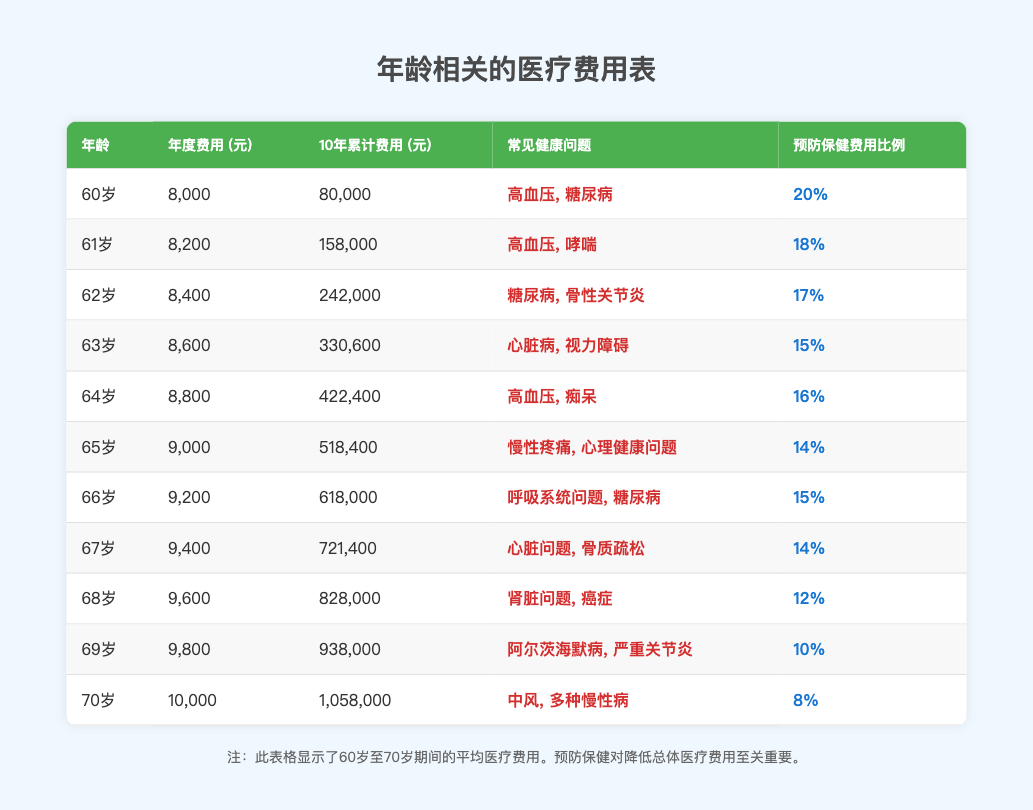What is the annual healthcare cost for a 65-year-old? The table shows that the annual cost for a 65-year-old is listed under "年度费用" as 9,000元.
Answer: 9,000元 What are the common health issues for a 67-year-old? According to the table, the common health issues for a 67-year-old are "心脏问题, 骨质疏松".
Answer: 心脏问题, 骨质疏松 What is the cumulative healthcare cost over 10 years for someone aged 64? The table states that the cumulative cost over 10 years for a 64-year-old is listed as 422,400元 under "10年累计费用".
Answer: 422,400元 What is the percentage of healthcare costs allocated for preventive care for a 69-year-old? From the table, the percentage of cost for preventive care for a 69-year-old is shown as 10% in the corresponding column.
Answer: 10% What is the difference in annual healthcare costs between a 60-year-old and a 70-year-old? The annual cost for a 60-year-old is 8,000元 and for a 70-year-old is 10,000元. The difference is 10,000 - 8,000 = 2,000元.
Answer: 2,000元 Is the percentage of costs for preventive care decreasing as age increases? By looking at the table, the percentages for preventive care are decreasing from 20% at age 60 to 8% at age 70, confirming the statement is true.
Answer: Yes What is the total cumulative cost for individuals aged 60 to 65 over 10 years? To find the total cumulative cost, we add the cumulative costs for ages 60 (80,000元), 61 (158,000元), 62 (242,000元), 63 (330,600元), 64 (422,400元), and 65 (518,400元): 80,000 + 158,000 + 242,000 + 330,600 + 422,400 + 518,400 = 1,307,400元.
Answer: 1,307,400元 What common health issues are associated with individuals aged 68? The table indicates that the common health issues for 68-year-olds are "肾脏问题, 癌症".
Answer: 肾脏问题, 癌症 How much more does a 70-year-old spend on healthcare annually compared to a 66-year-old? The annual cost for a 70-year-old is 10,000元 and for a 66-year-old is 9,200元. The difference is 10,000 - 9,200 = 800元.
Answer: 800元 